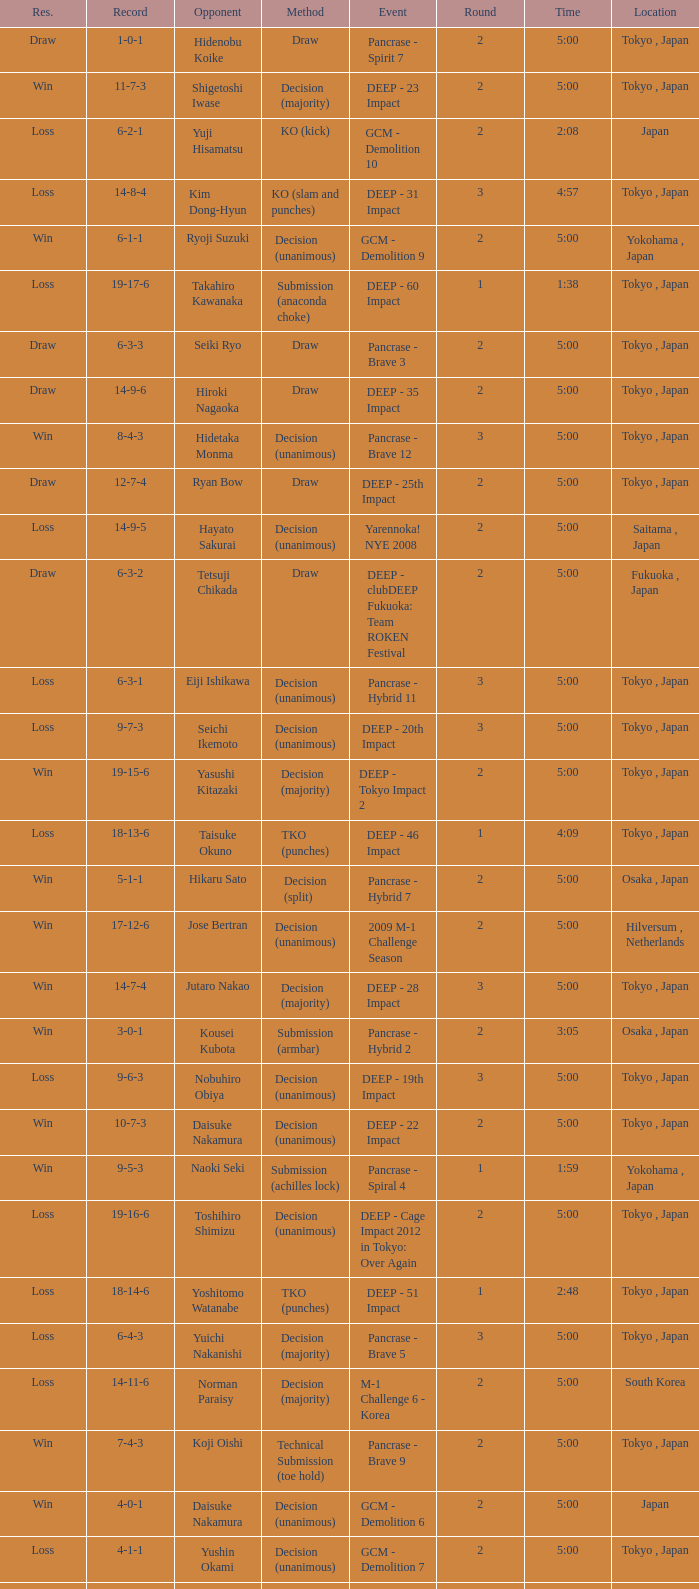What is the location when the record is 5-1-1? Osaka , Japan. 